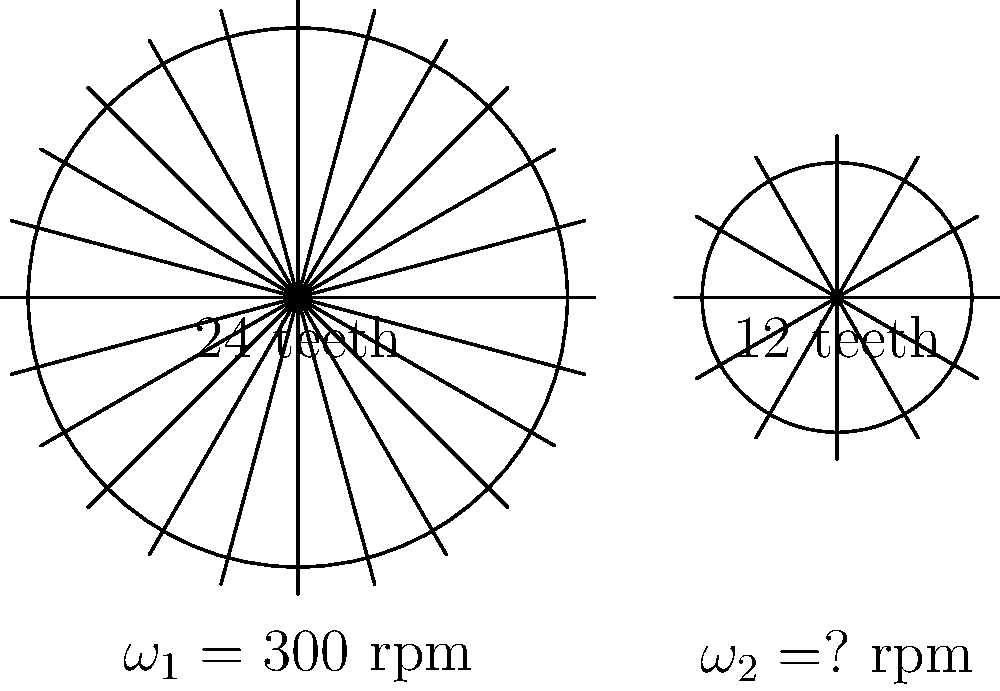In a simple gear train system, as shown in the diagram, the driving gear has 24 teeth and rotates at $\omega_1 = 300$ rpm (revolutions per minute). The driven gear has 12 teeth. Assuming no slippage occurs, calculate the rotational speed $\omega_2$ of the driven gear in rpm. How might this mechanical concept relate to the rhythmic patterns in spoken language, a topic of interest in sociolinguistics? Let's approach this step-by-step:

1) In a gear train, the relationship between the number of teeth and rotational speeds of two meshing gears is given by:

   $$\frac{\omega_1}{\omega_2} = \frac{N_2}{N_1}$$

   Where $\omega_1$ and $\omega_2$ are the angular velocities, and $N_1$ and $N_2$ are the number of teeth on the driving and driven gears respectively.

2) We know:
   - $\omega_1 = 300$ rpm
   - $N_1 = 24$ teeth
   - $N_2 = 12$ teeth

3) Substituting these values into the equation:

   $$\frac{300}{\omega_2} = \frac{12}{24}$$

4) Simplifying:

   $$\frac{300}{\omega_2} = \frac{1}{2}$$

5) Solving for $\omega_2$:

   $$\omega_2 = 300 \cdot 2 = 600 \text{ rpm}$$

Relating this to sociolinguistics:
This mechanical concept of gear ratios and rotational speeds can be metaphorically related to the rhythmic patterns in spoken language. Just as gears transmit motion at different speeds, speakers of a language can adjust their speech rate and rhythmic patterns. In sociolinguistics, these variations can be studied to understand how social factors influence speech patterns. For example, just as a smaller gear rotates faster when driven by a larger gear, speakers might increase their speech rate in certain social contexts or when discussing certain topics. This analogy could provide an interesting framework for analyzing the tempo and rhythmic aspects of speech in sociolinguistic studies.
Answer: 600 rpm 